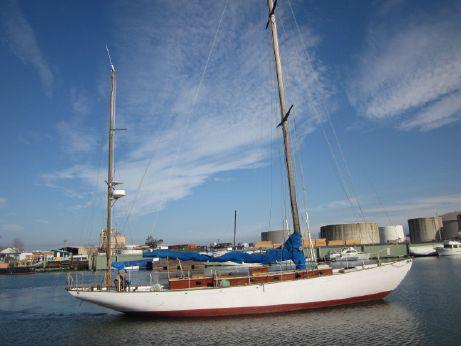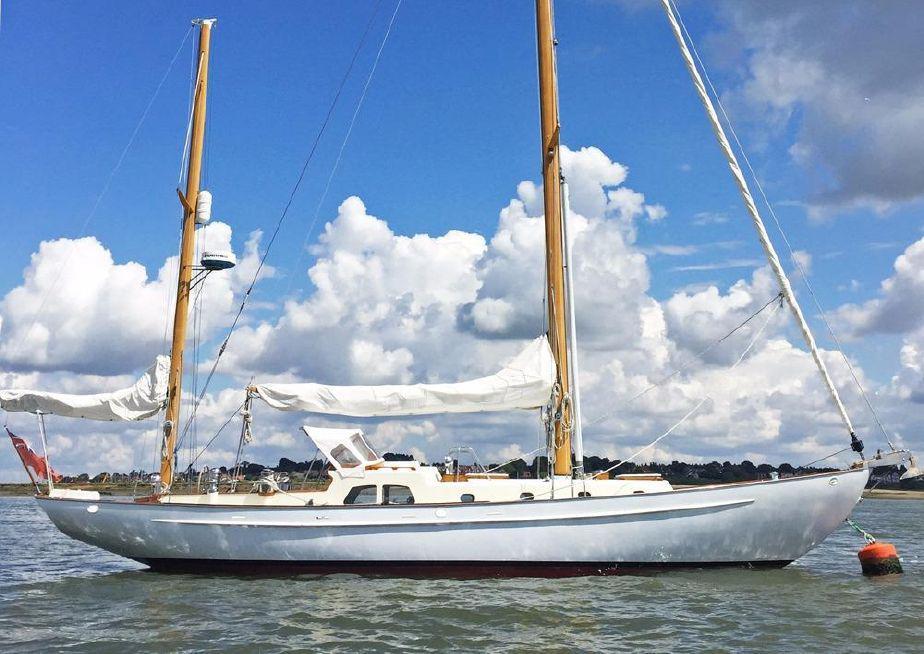The first image is the image on the left, the second image is the image on the right. Evaluate the accuracy of this statement regarding the images: "There is a ship with at least one sail unfurled.". Is it true? Answer yes or no. No. The first image is the image on the left, the second image is the image on the right. Given the left and right images, does the statement "the boats in the image pair have no sails raised" hold true? Answer yes or no. Yes. 